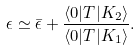<formula> <loc_0><loc_0><loc_500><loc_500>\epsilon \simeq \bar { \epsilon } + \frac { \langle 0 | T | K _ { 2 } \rangle } { \langle 0 | T | K _ { 1 } \rangle } .</formula> 